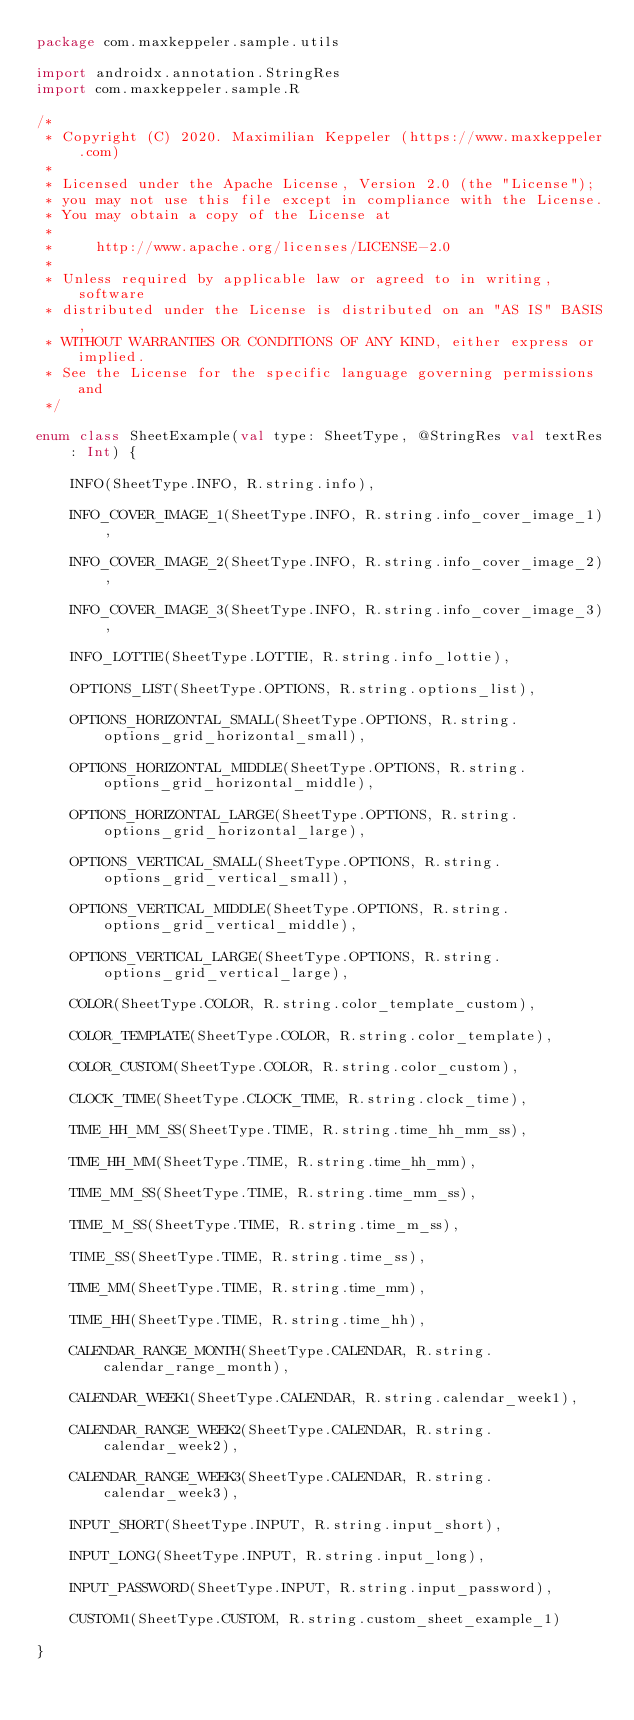Convert code to text. <code><loc_0><loc_0><loc_500><loc_500><_Kotlin_>package com.maxkeppeler.sample.utils

import androidx.annotation.StringRes
import com.maxkeppeler.sample.R

/*
 * Copyright (C) 2020. Maximilian Keppeler (https://www.maxkeppeler.com)
 *
 * Licensed under the Apache License, Version 2.0 (the "License");
 * you may not use this file except in compliance with the License.
 * You may obtain a copy of the License at
 *
 *     http://www.apache.org/licenses/LICENSE-2.0
 *
 * Unless required by applicable law or agreed to in writing, software
 * distributed under the License is distributed on an "AS IS" BASIS,
 * WITHOUT WARRANTIES OR CONDITIONS OF ANY KIND, either express or implied.
 * See the License for the specific language governing permissions and
 */

enum class SheetExample(val type: SheetType, @StringRes val textRes: Int) {

    INFO(SheetType.INFO, R.string.info),

    INFO_COVER_IMAGE_1(SheetType.INFO, R.string.info_cover_image_1),

    INFO_COVER_IMAGE_2(SheetType.INFO, R.string.info_cover_image_2),

    INFO_COVER_IMAGE_3(SheetType.INFO, R.string.info_cover_image_3),

    INFO_LOTTIE(SheetType.LOTTIE, R.string.info_lottie),

    OPTIONS_LIST(SheetType.OPTIONS, R.string.options_list),

    OPTIONS_HORIZONTAL_SMALL(SheetType.OPTIONS, R.string.options_grid_horizontal_small),

    OPTIONS_HORIZONTAL_MIDDLE(SheetType.OPTIONS, R.string.options_grid_horizontal_middle),

    OPTIONS_HORIZONTAL_LARGE(SheetType.OPTIONS, R.string.options_grid_horizontal_large),

    OPTIONS_VERTICAL_SMALL(SheetType.OPTIONS, R.string.options_grid_vertical_small),

    OPTIONS_VERTICAL_MIDDLE(SheetType.OPTIONS, R.string.options_grid_vertical_middle),

    OPTIONS_VERTICAL_LARGE(SheetType.OPTIONS, R.string.options_grid_vertical_large),

    COLOR(SheetType.COLOR, R.string.color_template_custom),

    COLOR_TEMPLATE(SheetType.COLOR, R.string.color_template),

    COLOR_CUSTOM(SheetType.COLOR, R.string.color_custom),

    CLOCK_TIME(SheetType.CLOCK_TIME, R.string.clock_time),

    TIME_HH_MM_SS(SheetType.TIME, R.string.time_hh_mm_ss),

    TIME_HH_MM(SheetType.TIME, R.string.time_hh_mm),

    TIME_MM_SS(SheetType.TIME, R.string.time_mm_ss),

    TIME_M_SS(SheetType.TIME, R.string.time_m_ss),

    TIME_SS(SheetType.TIME, R.string.time_ss),

    TIME_MM(SheetType.TIME, R.string.time_mm),

    TIME_HH(SheetType.TIME, R.string.time_hh),

    CALENDAR_RANGE_MONTH(SheetType.CALENDAR, R.string.calendar_range_month),

    CALENDAR_WEEK1(SheetType.CALENDAR, R.string.calendar_week1),

    CALENDAR_RANGE_WEEK2(SheetType.CALENDAR, R.string.calendar_week2),

    CALENDAR_RANGE_WEEK3(SheetType.CALENDAR, R.string.calendar_week3),

    INPUT_SHORT(SheetType.INPUT, R.string.input_short),

    INPUT_LONG(SheetType.INPUT, R.string.input_long),

    INPUT_PASSWORD(SheetType.INPUT, R.string.input_password),

    CUSTOM1(SheetType.CUSTOM, R.string.custom_sheet_example_1)

}
</code> 